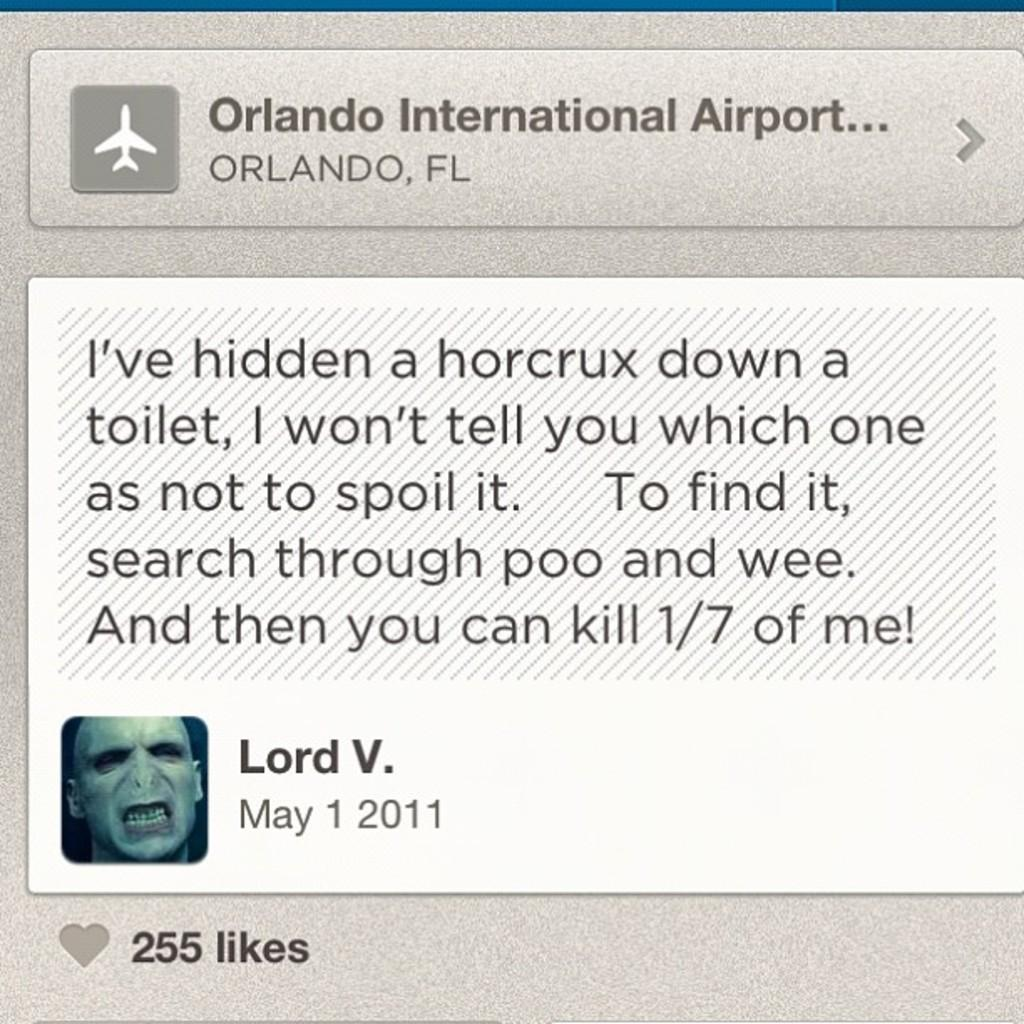What can be found in the image that contains written information? There is text in the image. What is depicted in the image alongside the text? There is a photo of a person in the image. What type of chair is visible in the image? There is no chair present in the image. Can you hear the person's voice in the image? The image is static, so it does not contain any audible information, such as a person's voice. 